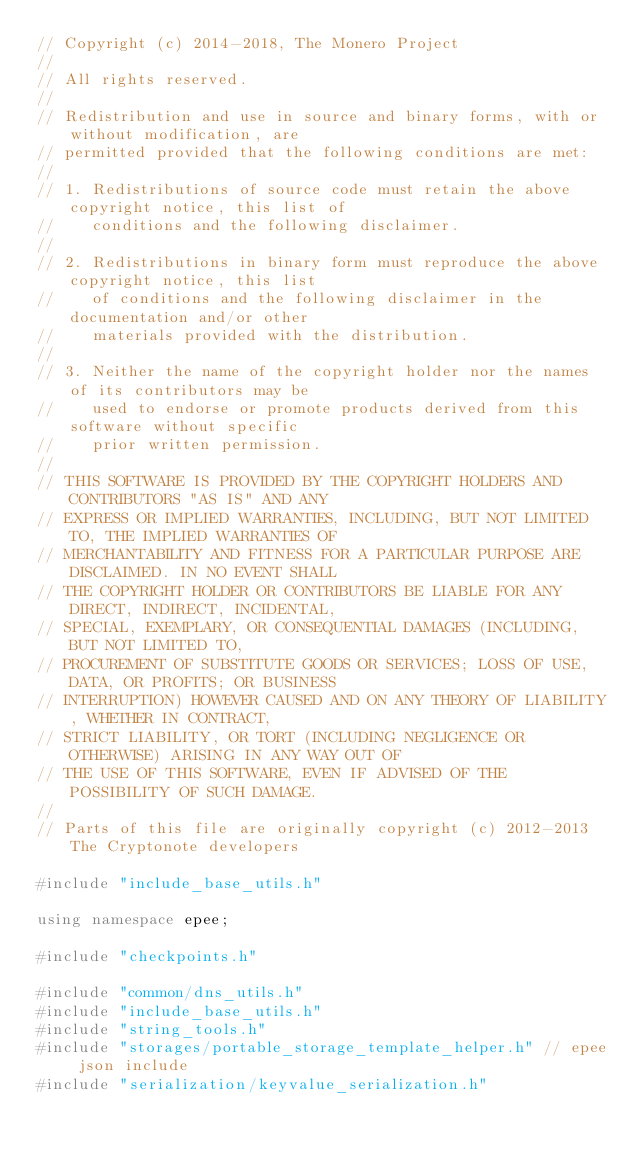Convert code to text. <code><loc_0><loc_0><loc_500><loc_500><_C++_>// Copyright (c) 2014-2018, The Monero Project
//
// All rights reserved.
//
// Redistribution and use in source and binary forms, with or without modification, are
// permitted provided that the following conditions are met:
//
// 1. Redistributions of source code must retain the above copyright notice, this list of
//    conditions and the following disclaimer.
//
// 2. Redistributions in binary form must reproduce the above copyright notice, this list
//    of conditions and the following disclaimer in the documentation and/or other
//    materials provided with the distribution.
//
// 3. Neither the name of the copyright holder nor the names of its contributors may be
//    used to endorse or promote products derived from this software without specific
//    prior written permission.
//
// THIS SOFTWARE IS PROVIDED BY THE COPYRIGHT HOLDERS AND CONTRIBUTORS "AS IS" AND ANY
// EXPRESS OR IMPLIED WARRANTIES, INCLUDING, BUT NOT LIMITED TO, THE IMPLIED WARRANTIES OF
// MERCHANTABILITY AND FITNESS FOR A PARTICULAR PURPOSE ARE DISCLAIMED. IN NO EVENT SHALL
// THE COPYRIGHT HOLDER OR CONTRIBUTORS BE LIABLE FOR ANY DIRECT, INDIRECT, INCIDENTAL,
// SPECIAL, EXEMPLARY, OR CONSEQUENTIAL DAMAGES (INCLUDING, BUT NOT LIMITED TO,
// PROCUREMENT OF SUBSTITUTE GOODS OR SERVICES; LOSS OF USE, DATA, OR PROFITS; OR BUSINESS
// INTERRUPTION) HOWEVER CAUSED AND ON ANY THEORY OF LIABILITY, WHETHER IN CONTRACT,
// STRICT LIABILITY, OR TORT (INCLUDING NEGLIGENCE OR OTHERWISE) ARISING IN ANY WAY OUT OF
// THE USE OF THIS SOFTWARE, EVEN IF ADVISED OF THE POSSIBILITY OF SUCH DAMAGE.
//
// Parts of this file are originally copyright (c) 2012-2013 The Cryptonote developers

#include "include_base_utils.h"

using namespace epee;

#include "checkpoints.h"

#include "common/dns_utils.h"
#include "include_base_utils.h"
#include "string_tools.h"
#include "storages/portable_storage_template_helper.h" // epee json include
#include "serialization/keyvalue_serialization.h"
</code> 